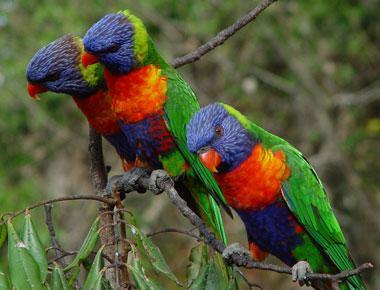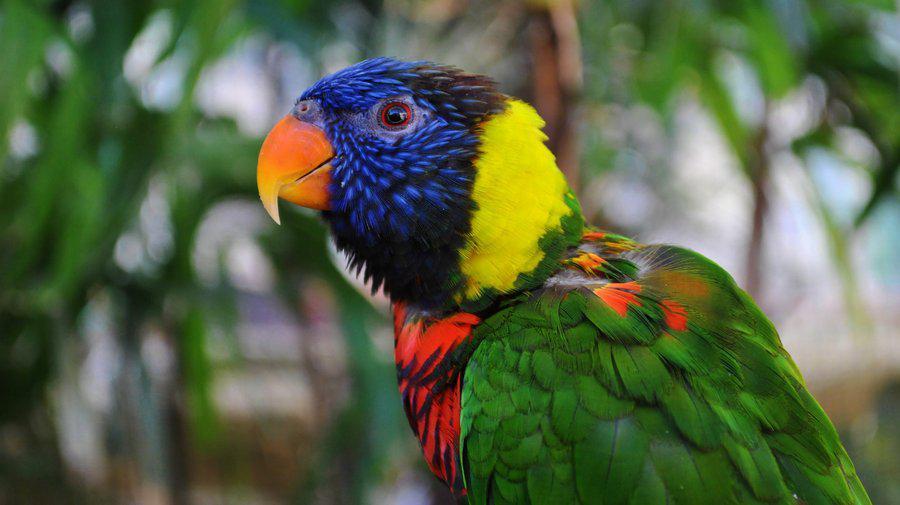The first image is the image on the left, the second image is the image on the right. Assess this claim about the two images: "There are three birds". Correct or not? Answer yes or no. No. 